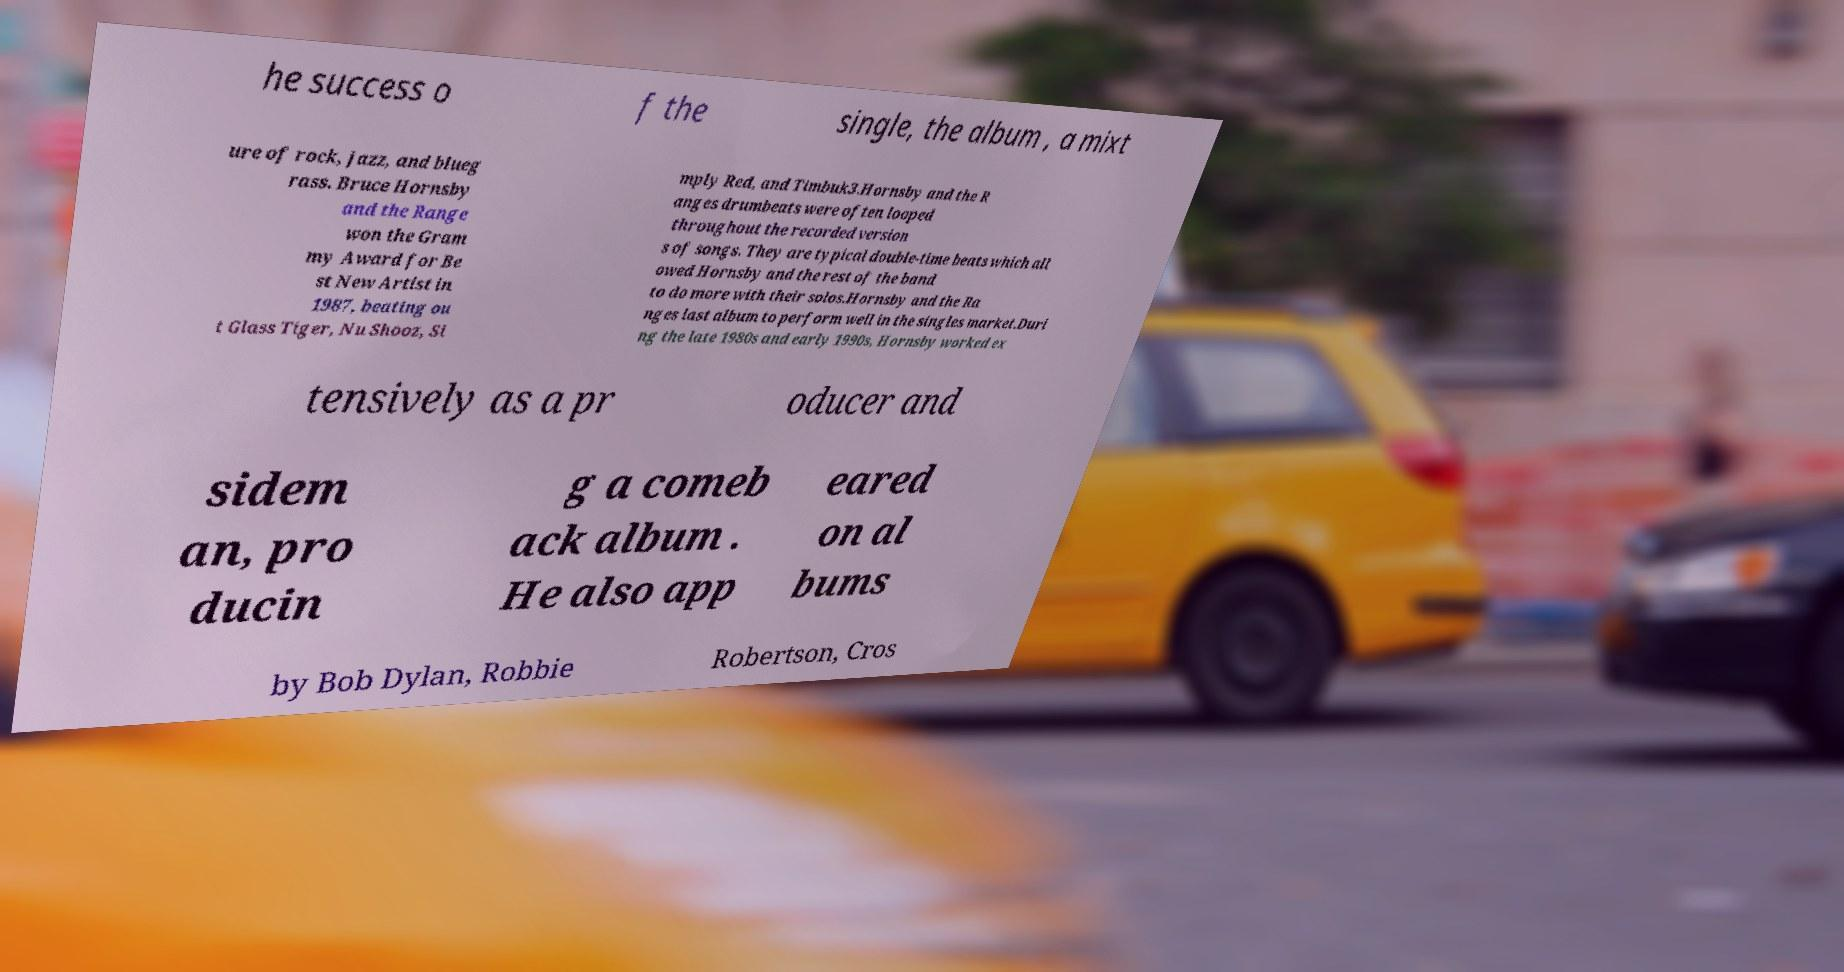Please read and relay the text visible in this image. What does it say? he success o f the single, the album , a mixt ure of rock, jazz, and blueg rass. Bruce Hornsby and the Range won the Gram my Award for Be st New Artist in 1987, beating ou t Glass Tiger, Nu Shooz, Si mply Red, and Timbuk3.Hornsby and the R anges drumbeats were often looped throughout the recorded version s of songs. They are typical double-time beats which all owed Hornsby and the rest of the band to do more with their solos.Hornsby and the Ra nges last album to perform well in the singles market.Duri ng the late 1980s and early 1990s, Hornsby worked ex tensively as a pr oducer and sidem an, pro ducin g a comeb ack album . He also app eared on al bums by Bob Dylan, Robbie Robertson, Cros 